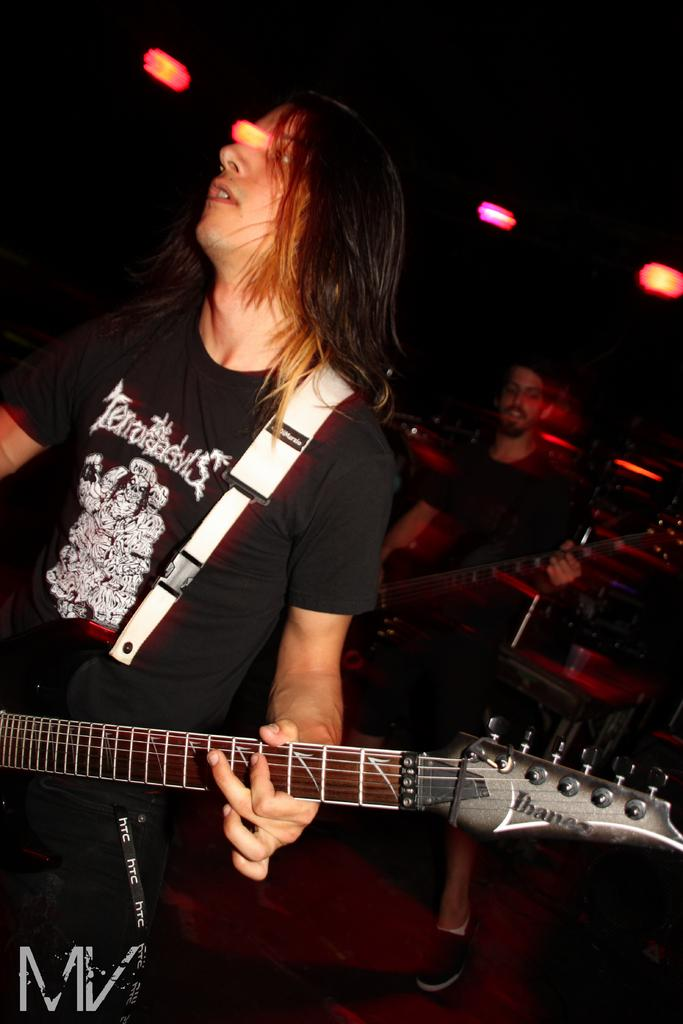What are the two people in the image doing? One person is standing and holding a guitar, while the other person is standing and playing a guitar. Can you describe the actions of the person holding the guitar? The person holding the guitar is standing and gripping the instrument. What is the other person doing with their guitar? The other person is playing the guitar, which involves strumming or plucking the strings. What type of leather is visible on the scene in the image? There is no leather visible in the image, as it features two people holding and playing guitars. How many hands are visible in the image? The number of hands visible in the image cannot be determined without additional information, as the image only shows the two people from the waist up. 